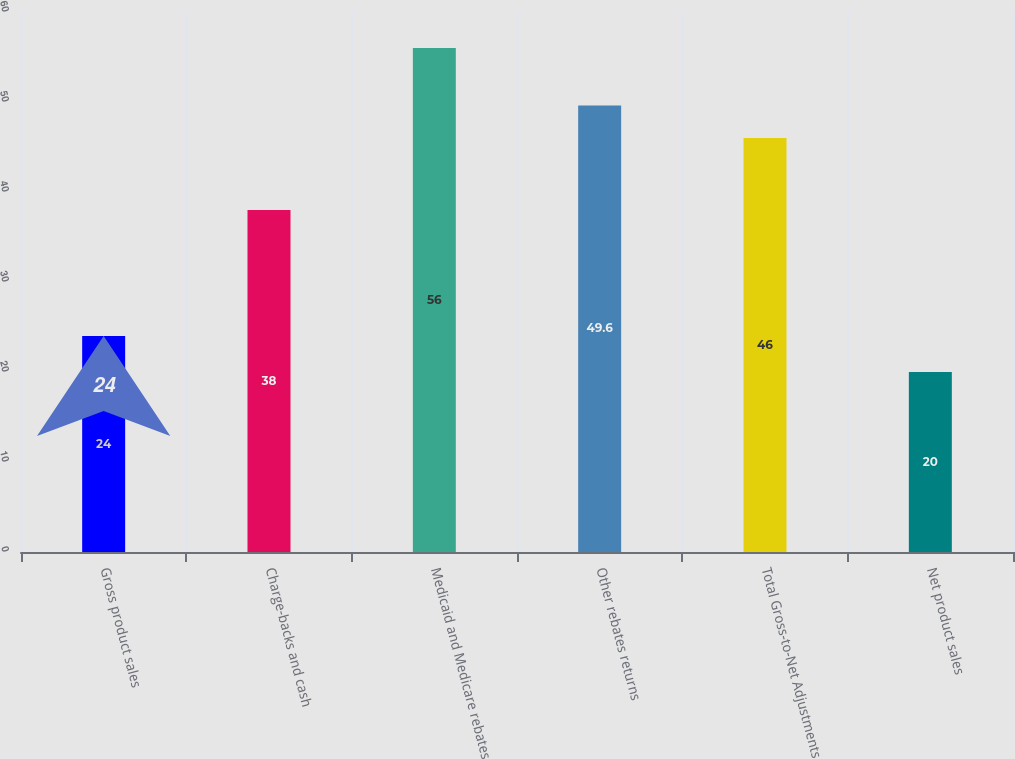<chart> <loc_0><loc_0><loc_500><loc_500><bar_chart><fcel>Gross product sales<fcel>Charge-backs and cash<fcel>Medicaid and Medicare rebates<fcel>Other rebates returns<fcel>Total Gross-to-Net Adjustments<fcel>Net product sales<nl><fcel>24<fcel>38<fcel>56<fcel>49.6<fcel>46<fcel>20<nl></chart> 